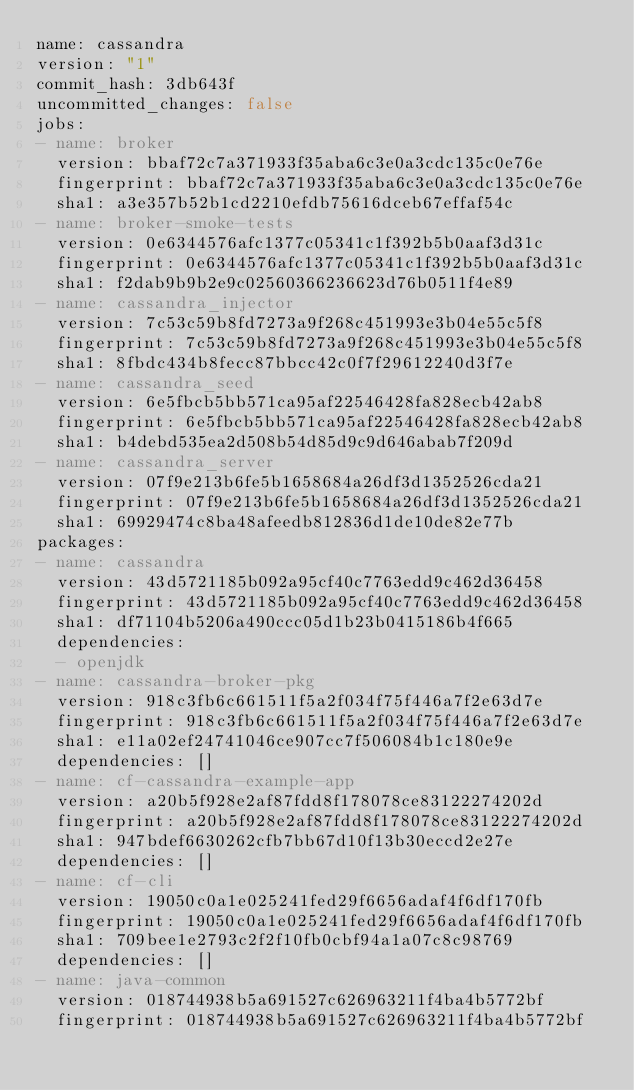<code> <loc_0><loc_0><loc_500><loc_500><_YAML_>name: cassandra
version: "1"
commit_hash: 3db643f
uncommitted_changes: false
jobs:
- name: broker
  version: bbaf72c7a371933f35aba6c3e0a3cdc135c0e76e
  fingerprint: bbaf72c7a371933f35aba6c3e0a3cdc135c0e76e
  sha1: a3e357b52b1cd2210efdb75616dceb67effaf54c
- name: broker-smoke-tests
  version: 0e6344576afc1377c05341c1f392b5b0aaf3d31c
  fingerprint: 0e6344576afc1377c05341c1f392b5b0aaf3d31c
  sha1: f2dab9b9b2e9c02560366236623d76b0511f4e89
- name: cassandra_injector
  version: 7c53c59b8fd7273a9f268c451993e3b04e55c5f8
  fingerprint: 7c53c59b8fd7273a9f268c451993e3b04e55c5f8
  sha1: 8fbdc434b8fecc87bbcc42c0f7f29612240d3f7e
- name: cassandra_seed
  version: 6e5fbcb5bb571ca95af22546428fa828ecb42ab8
  fingerprint: 6e5fbcb5bb571ca95af22546428fa828ecb42ab8
  sha1: b4debd535ea2d508b54d85d9c9d646abab7f209d
- name: cassandra_server
  version: 07f9e213b6fe5b1658684a26df3d1352526cda21
  fingerprint: 07f9e213b6fe5b1658684a26df3d1352526cda21
  sha1: 69929474c8ba48afeedb812836d1de10de82e77b
packages:
- name: cassandra
  version: 43d5721185b092a95cf40c7763edd9c462d36458
  fingerprint: 43d5721185b092a95cf40c7763edd9c462d36458
  sha1: df71104b5206a490ccc05d1b23b0415186b4f665
  dependencies:
  - openjdk
- name: cassandra-broker-pkg
  version: 918c3fb6c661511f5a2f034f75f446a7f2e63d7e
  fingerprint: 918c3fb6c661511f5a2f034f75f446a7f2e63d7e
  sha1: e11a02ef24741046ce907cc7f506084b1c180e9e
  dependencies: []
- name: cf-cassandra-example-app
  version: a20b5f928e2af87fdd8f178078ce83122274202d
  fingerprint: a20b5f928e2af87fdd8f178078ce83122274202d
  sha1: 947bdef6630262cfb7bb67d10f13b30eccd2e27e
  dependencies: []
- name: cf-cli
  version: 19050c0a1e025241fed29f6656adaf4f6df170fb
  fingerprint: 19050c0a1e025241fed29f6656adaf4f6df170fb
  sha1: 709bee1e2793c2f2f10fb0cbf94a1a07c8c98769
  dependencies: []
- name: java-common
  version: 018744938b5a691527c626963211f4ba4b5772bf
  fingerprint: 018744938b5a691527c626963211f4ba4b5772bf</code> 